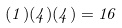Convert formula to latex. <formula><loc_0><loc_0><loc_500><loc_500>( 1 ) ( 4 ) ( 4 ) = 1 6</formula> 